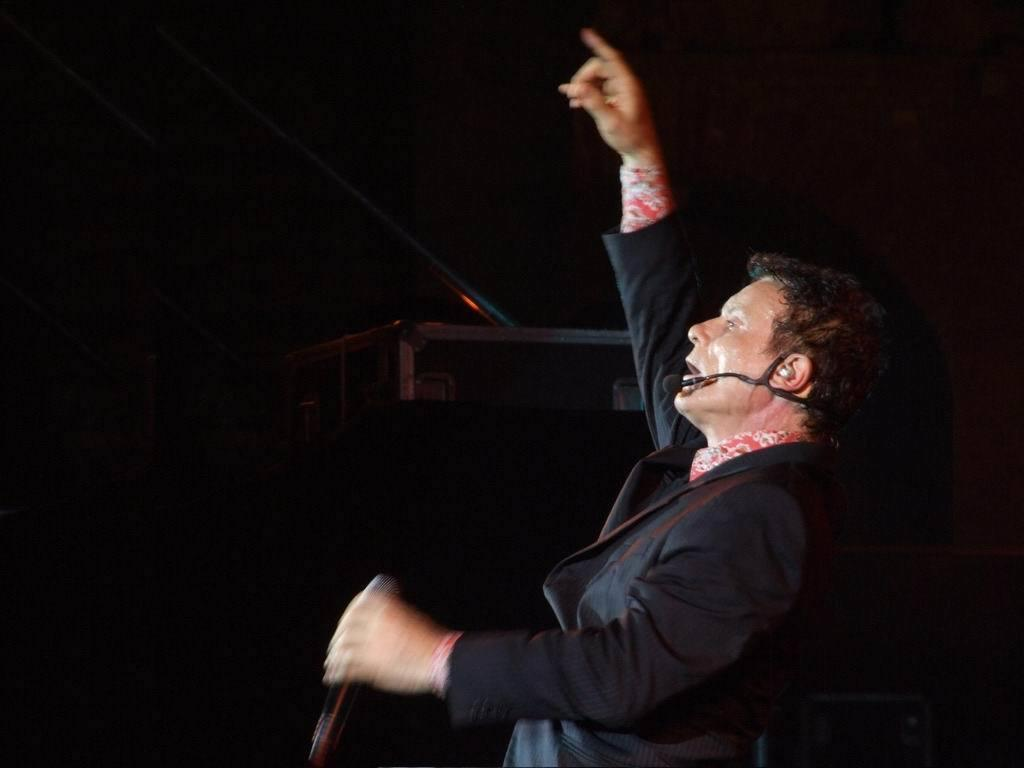Who is present in the image? There is a man in the image. What is the man holding in the image? The man is holding a microphone. What can be seen in the background of the image? There is a podium and a stand in the background of the image. What type of poison is the man using on his eye in the image? There is no poison or any indication of the man's eye in the image. What type of beef is being served on the stand in the image? There is no beef or any food items present on the stand in the image. 